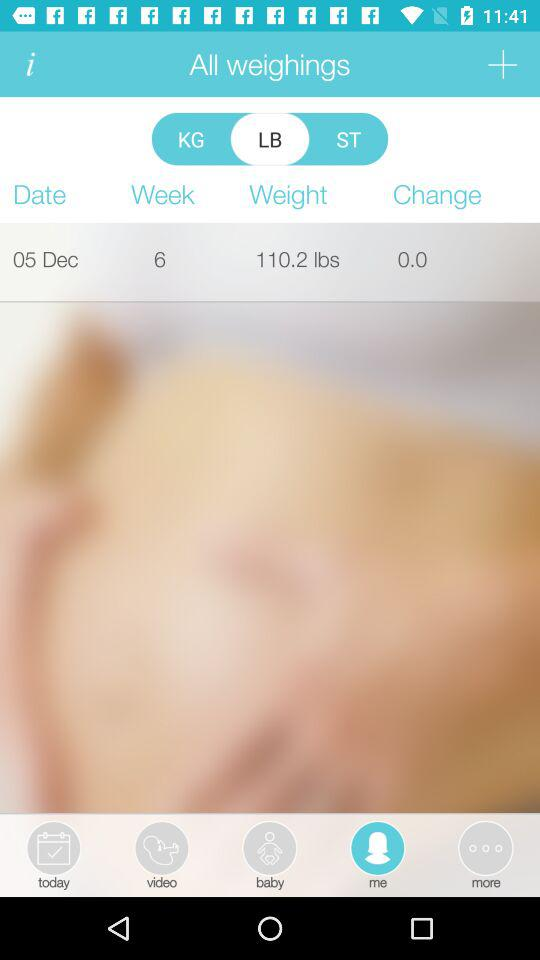What is the weight? The weight is 110.2 lbs. 